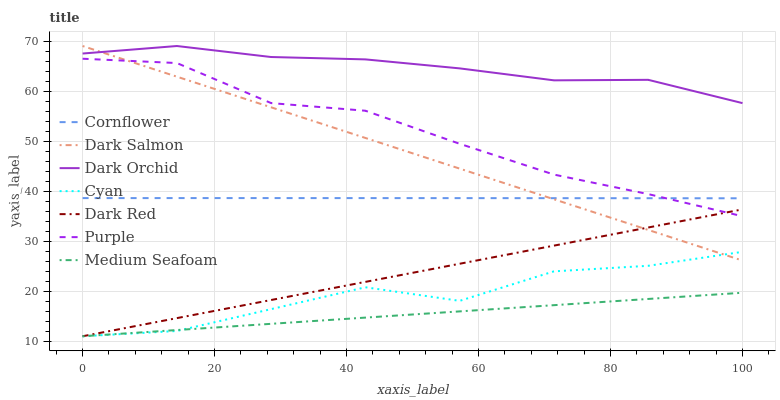Does Medium Seafoam have the minimum area under the curve?
Answer yes or no. Yes. Does Dark Orchid have the maximum area under the curve?
Answer yes or no. Yes. Does Purple have the minimum area under the curve?
Answer yes or no. No. Does Purple have the maximum area under the curve?
Answer yes or no. No. Is Medium Seafoam the smoothest?
Answer yes or no. Yes. Is Cyan the roughest?
Answer yes or no. Yes. Is Purple the smoothest?
Answer yes or no. No. Is Purple the roughest?
Answer yes or no. No. Does Dark Red have the lowest value?
Answer yes or no. Yes. Does Purple have the lowest value?
Answer yes or no. No. Does Dark Orchid have the highest value?
Answer yes or no. Yes. Does Purple have the highest value?
Answer yes or no. No. Is Cyan less than Purple?
Answer yes or no. Yes. Is Dark Orchid greater than Cornflower?
Answer yes or no. Yes. Does Cornflower intersect Dark Salmon?
Answer yes or no. Yes. Is Cornflower less than Dark Salmon?
Answer yes or no. No. Is Cornflower greater than Dark Salmon?
Answer yes or no. No. Does Cyan intersect Purple?
Answer yes or no. No. 